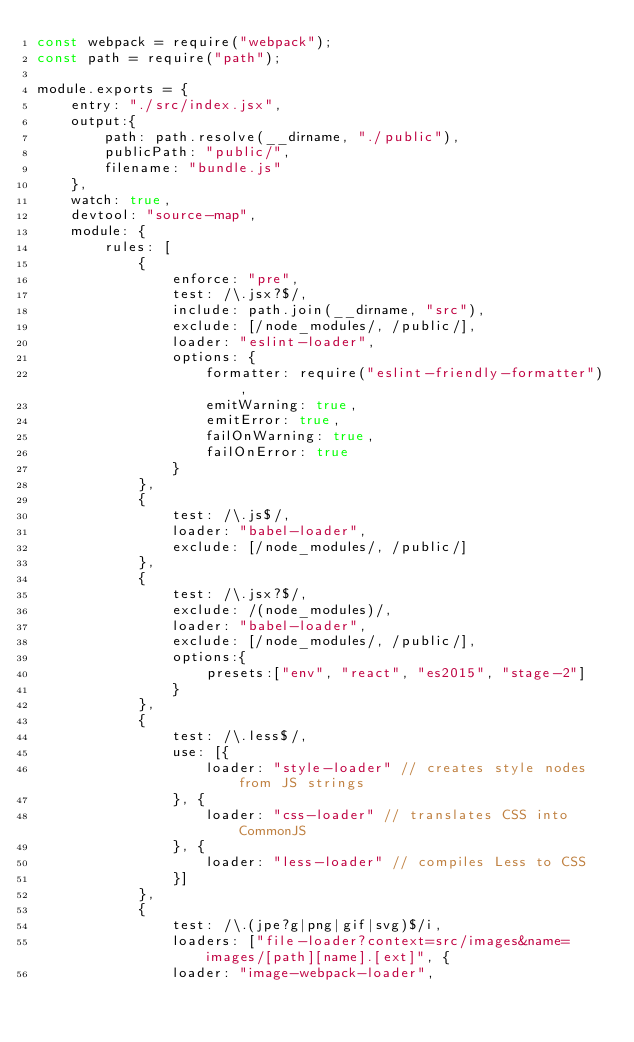Convert code to text. <code><loc_0><loc_0><loc_500><loc_500><_JavaScript_>const webpack = require("webpack");
const path = require("path");

module.exports = {
    entry: "./src/index.jsx",
    output:{
        path: path.resolve(__dirname, "./public"),
        publicPath: "public/",
        filename: "bundle.js"
    },
    watch: true,
    devtool: "source-map",
    module: {
        rules: [
            {
                enforce: "pre",
                test: /\.jsx?$/,
                include: path.join(__dirname, "src"),
                exclude: [/node_modules/, /public/],
                loader: "eslint-loader",
                options: {
                    formatter: require("eslint-friendly-formatter"),
                    emitWarning: true,
                    emitError: true,
                    failOnWarning: true,
                    failOnError: true
                }
            },
            {
                test: /\.js$/,
                loader: "babel-loader",
                exclude: [/node_modules/, /public/]
            },
            {
                test: /\.jsx?$/,
                exclude: /(node_modules)/,
                loader: "babel-loader",
                exclude: [/node_modules/, /public/],
                options:{
                    presets:["env", "react", "es2015", "stage-2"]
                }
            },
            {
                test: /\.less$/,
                use: [{
                    loader: "style-loader" // creates style nodes from JS strings
                }, {
                    loader: "css-loader" // translates CSS into CommonJS
                }, {
                    loader: "less-loader" // compiles Less to CSS
                }]
            },
            {
                test: /\.(jpe?g|png|gif|svg)$/i,
                loaders: ["file-loader?context=src/images&name=images/[path][name].[ext]", {
                loader: "image-webpack-loader",</code> 